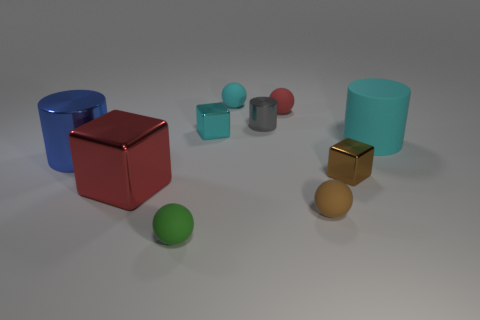There is a tiny ball that is the same color as the big matte cylinder; what material is it?
Offer a very short reply. Rubber. There is a tiny block right of the small cyan metallic thing; is its color the same as the matte sphere to the right of the red matte sphere?
Your answer should be very brief. Yes. What size is the matte ball that is the same color as the big rubber cylinder?
Your response must be concise. Small. There is a cyan cylinder; how many cyan matte spheres are right of it?
Your response must be concise. 0. What number of other objects are there of the same shape as the small cyan rubber thing?
Your answer should be very brief. 3. Are there fewer big brown cylinders than small cubes?
Ensure brevity in your answer.  Yes. There is a cylinder that is both on the right side of the green object and to the left of the cyan rubber cylinder; what is its size?
Give a very brief answer. Small. What is the size of the red thing that is behind the metallic block that is to the right of the tiny red thing right of the small green thing?
Make the answer very short. Small. The green object is what size?
Provide a short and direct response. Small. There is a red object behind the cylinder in front of the big cyan rubber object; is there a small metal cube that is in front of it?
Provide a short and direct response. Yes. 